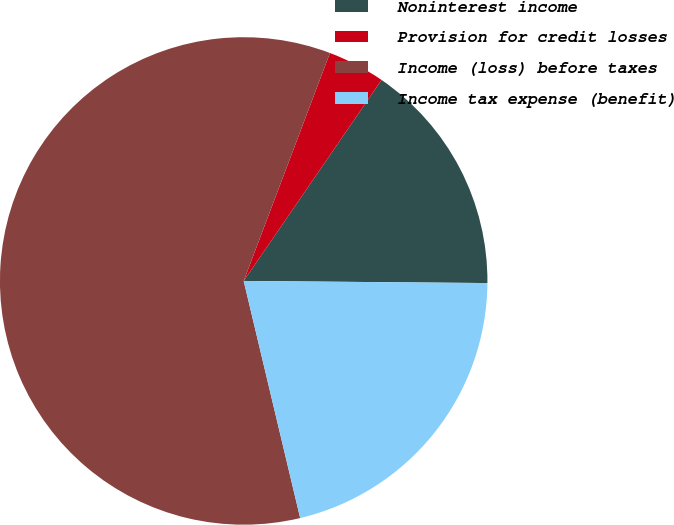<chart> <loc_0><loc_0><loc_500><loc_500><pie_chart><fcel>Noninterest income<fcel>Provision for credit losses<fcel>Income (loss) before taxes<fcel>Income tax expense (benefit)<nl><fcel>15.57%<fcel>3.81%<fcel>59.48%<fcel>21.14%<nl></chart> 